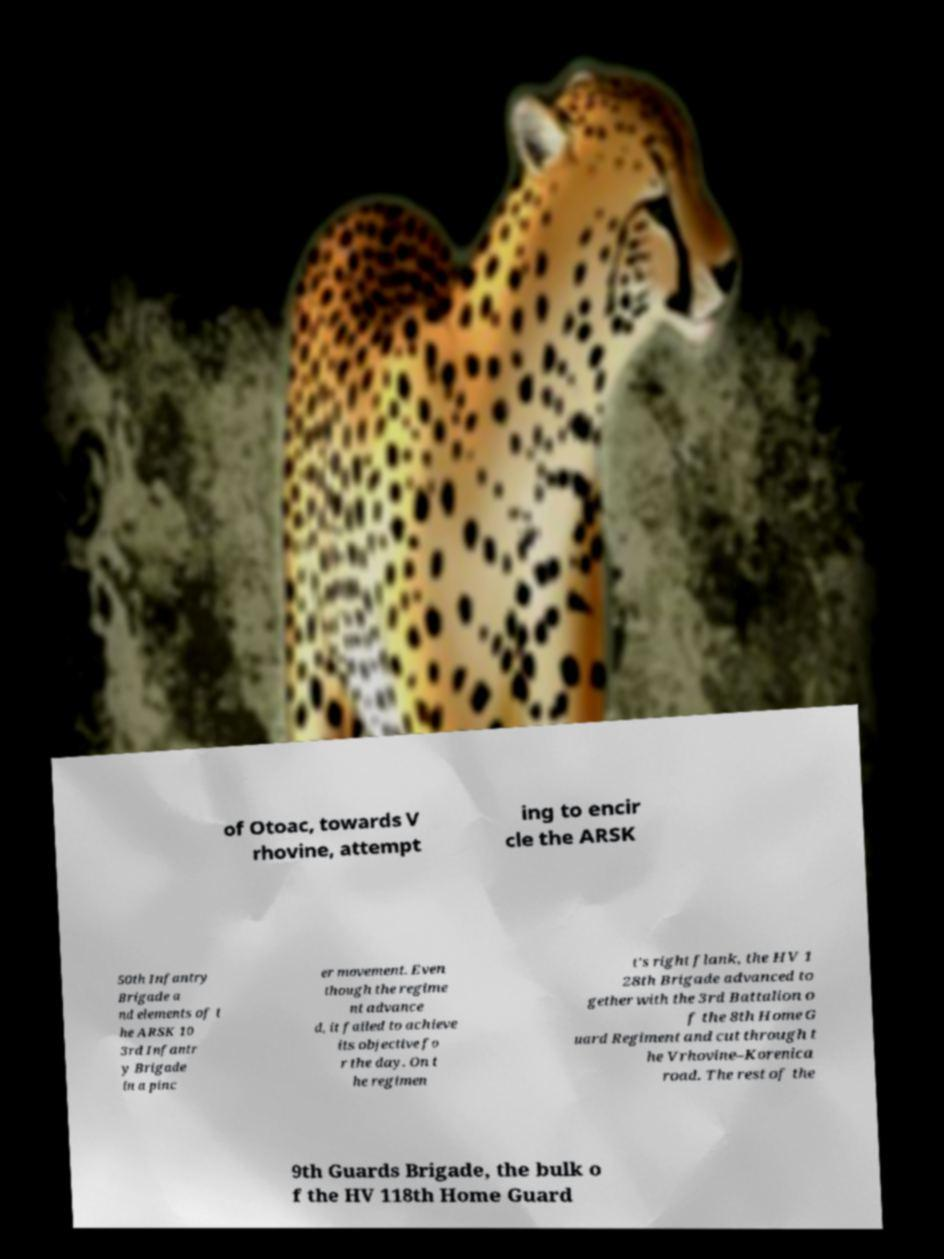Can you accurately transcribe the text from the provided image for me? of Otoac, towards V rhovine, attempt ing to encir cle the ARSK 50th Infantry Brigade a nd elements of t he ARSK 10 3rd Infantr y Brigade in a pinc er movement. Even though the regime nt advance d, it failed to achieve its objective fo r the day. On t he regimen t's right flank, the HV 1 28th Brigade advanced to gether with the 3rd Battalion o f the 8th Home G uard Regiment and cut through t he Vrhovine–Korenica road. The rest of the 9th Guards Brigade, the bulk o f the HV 118th Home Guard 